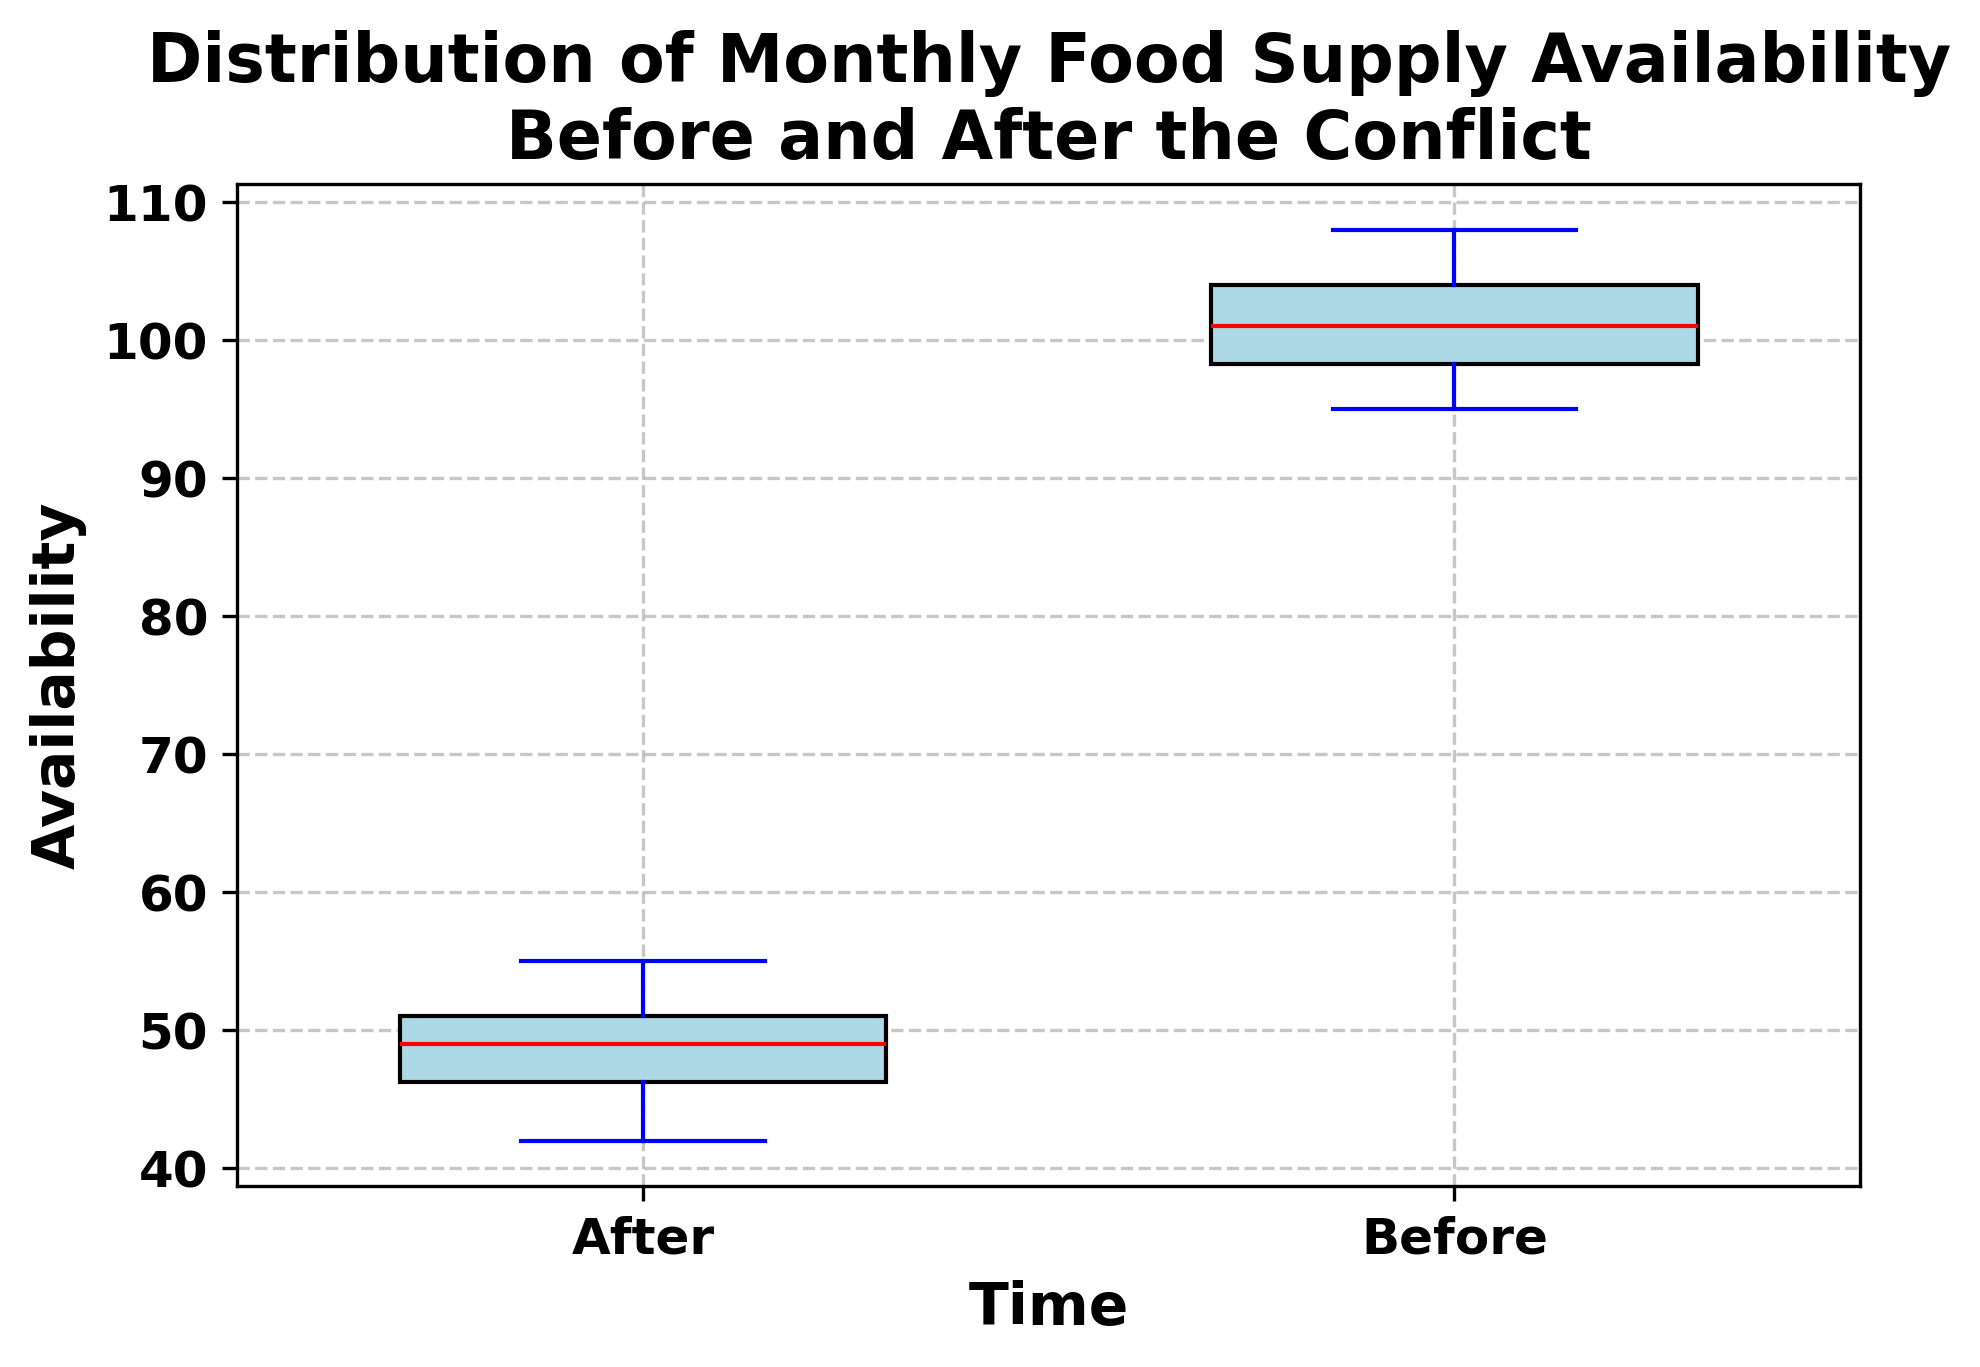What is the median food supply availability before the conflict? Look at the red line inside the box for the 'Before' group; the median represents the middle value of the dataset.
Answer: 101 Which period shows a wider distribution in food supply availability? Compare the width of the interquartile range (IQR) and the spread of the whiskers (lines extending from the boxes) for the 'Before' group and the 'After' group.
Answer: Before What is the difference between the median values of food supply availability before and after the conflict? Identify the median values from both periods and subtract the 'After' median from the 'Before' median: 101 - 48.5 = 52.5. Subtract the two medians: 101 - 48.5
Answer: 52.5 What is the interquartile range (IQR) for the food supply availability after the conflict? The IQR is the range between the first quartile (Q1, bottom of the box) and the third quartile (Q3, top of the box). Locate these values on the 'After' box, which are 46 and 51 respectively: 51 - 46 = 5.
Answer: 5 Which time period has the lower maximum food supply availability? Compare the maximum whisker values of both 'Before' and 'After' groups; the 'After' period shows a lower maximum availability.
Answer: After How does the minimum food supply availability compare between the two periods? Compare the bottom whiskers of both 'Before' and 'After' groups; the 'After' period has a lower minimum value.
Answer: After What can be said about the median food supply availability before and after the conflict in terms of color representation? Observe the red lines inside both boxes; the red lines indicate the median values for the periods 'Before' and 'After'.
Answer: The medians are represented in red Is the variability in food supply availability higher before or after the conflict? Look at the length of the whiskers and the height of the box (IQR); the 'Before' period has a greater spread and range in values, indicating higher variability.
Answer: Before Compare the range of food supply availability before and after the conflict. Calculate the range for both periods by subtracting the minimum value in the whiskers from the maximum value: Before: 108 - 95 = 13, After: 55 - 42 = 13.
Answer: Both have the same range of 13 What is the lower quartile (Q1) for the food supply availability before the conflict period? The lower quartile (Q1) is the bottom of the box for the 'Before' group, which can be visually checked on the plot.
Answer: 98 